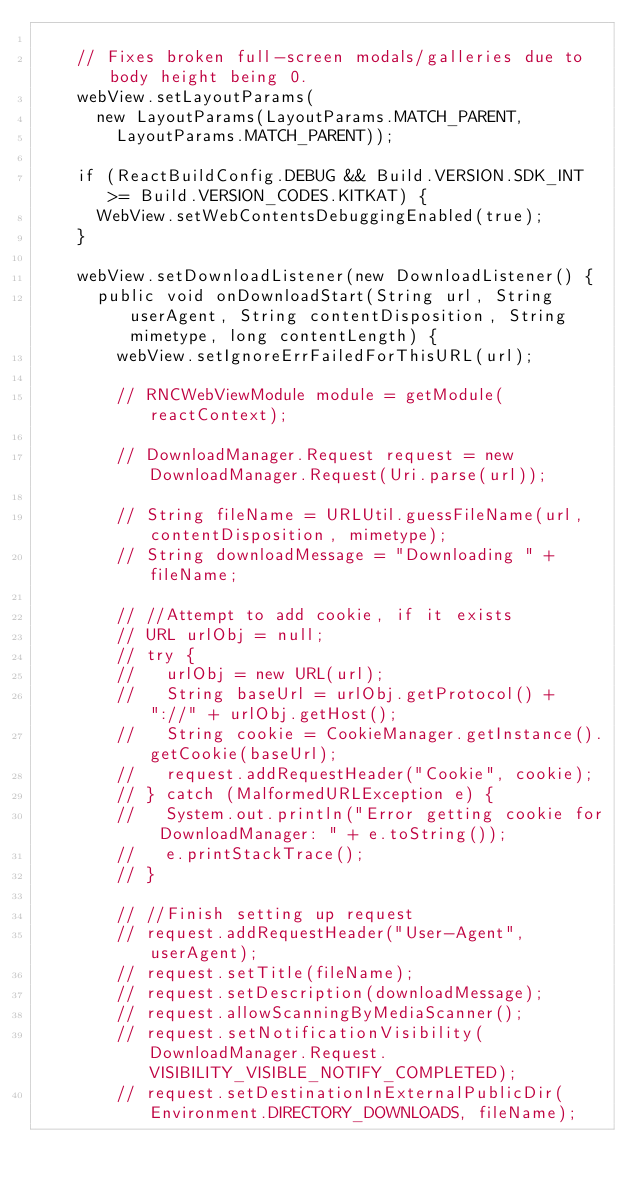<code> <loc_0><loc_0><loc_500><loc_500><_Java_>
    // Fixes broken full-screen modals/galleries due to body height being 0.
    webView.setLayoutParams(
      new LayoutParams(LayoutParams.MATCH_PARENT,
        LayoutParams.MATCH_PARENT));

    if (ReactBuildConfig.DEBUG && Build.VERSION.SDK_INT >= Build.VERSION_CODES.KITKAT) {
      WebView.setWebContentsDebuggingEnabled(true);
    }

    webView.setDownloadListener(new DownloadListener() {
      public void onDownloadStart(String url, String userAgent, String contentDisposition, String mimetype, long contentLength) {
        webView.setIgnoreErrFailedForThisURL(url);

        // RNCWebViewModule module = getModule(reactContext);

        // DownloadManager.Request request = new DownloadManager.Request(Uri.parse(url));

        // String fileName = URLUtil.guessFileName(url, contentDisposition, mimetype);
        // String downloadMessage = "Downloading " + fileName;

        // //Attempt to add cookie, if it exists
        // URL urlObj = null;
        // try {
        //   urlObj = new URL(url);
        //   String baseUrl = urlObj.getProtocol() + "://" + urlObj.getHost();
        //   String cookie = CookieManager.getInstance().getCookie(baseUrl);
        //   request.addRequestHeader("Cookie", cookie);
        // } catch (MalformedURLException e) {
        //   System.out.println("Error getting cookie for DownloadManager: " + e.toString());
        //   e.printStackTrace();
        // }

        // //Finish setting up request
        // request.addRequestHeader("User-Agent", userAgent);
        // request.setTitle(fileName);
        // request.setDescription(downloadMessage);
        // request.allowScanningByMediaScanner();
        // request.setNotificationVisibility(DownloadManager.Request.VISIBILITY_VISIBLE_NOTIFY_COMPLETED);
        // request.setDestinationInExternalPublicDir(Environment.DIRECTORY_DOWNLOADS, fileName);
</code> 